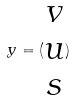<formula> <loc_0><loc_0><loc_500><loc_500>y = ( \begin{matrix} v \\ u \\ s \end{matrix} )</formula> 